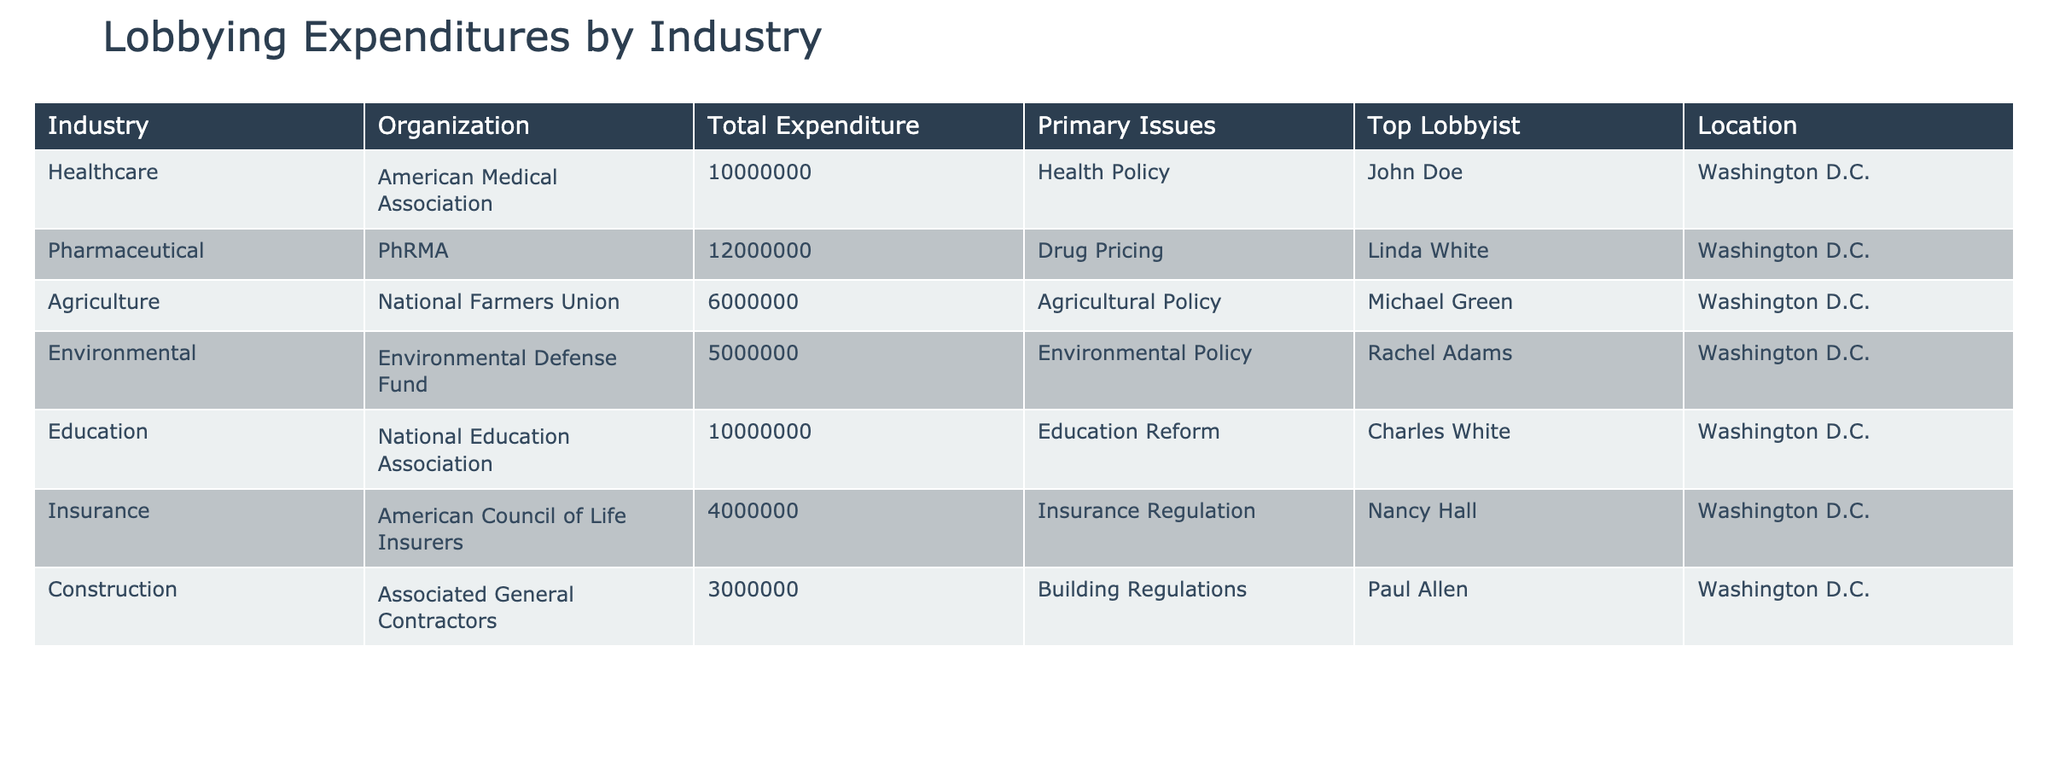What is the total expenditure for the Pharmaceutical industry? The table lists the total expenditure for the Pharmaceutical industry as 12,000,000.
Answer: 12,000,000 Which organization spent the most on lobbying? The highest total expenditure listed in the table is 12,000,000 by PhRMA in the Pharmaceutical industry, indicating it spent the most.
Answer: PhRMA What is the combined expenditure of the Healthcare and Education industries? Adding the expenditures from both industries, Healthcare (10,000,000) and Education (10,000,000), the total is 20,000,000.
Answer: 20,000,000 Is the American Medical Association located outside Washington D.C.? The table shows that the American Medical Association is located in Washington D.C., therefore the answer is no.
Answer: No Which industry had the lowest lobbying expenditure, and what was the amount? The lowest expenditure listed is 3,000,000 in the Construction industry, making it the least among all.
Answer: Construction, 3,000,000 What is the average expenditure for the Environmental and Agricultural industries? The Environmental industry spent 5,000,000 and the Agricultural industry spent 6,000,000. The average is (5,000,000 + 6,000,000) / 2 = 5,500,000.
Answer: 5,500,000 Do any organizations listed have an expenditure exceeding 10 million? Yes, both PhRMA (12,000,000) and the American Medical Association (10,000,000) have expenditures exceeding 10 million.
Answer: Yes Which top lobbyist is associated with the National Farmers Union? The National Farmers Union lists Michael Green as its top lobbyist according to the table.
Answer: Michael Green What percentage of the total expenditures (from all organizations) was spent by the American Council of Life Insurers? The total expenditures from the table amount to 54,000,000 (sum of all expenditures). The American Council of Life Insurers spent 4,000,000. The percentage is (4,000,000 / 54,000,000) * 100 = 7.41%.
Answer: 7.41% 